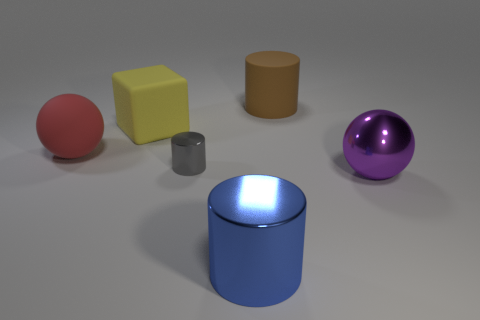Add 2 big yellow things. How many objects exist? 8 Subtract all metallic cylinders. How many cylinders are left? 1 Subtract all purple spheres. How many spheres are left? 1 Subtract all blocks. How many objects are left? 5 Subtract 1 spheres. How many spheres are left? 1 Subtract all big rubber spheres. Subtract all gray cylinders. How many objects are left? 4 Add 5 tiny gray things. How many tiny gray things are left? 6 Add 4 blue things. How many blue things exist? 5 Subtract 0 blue spheres. How many objects are left? 6 Subtract all purple balls. Subtract all cyan cubes. How many balls are left? 1 